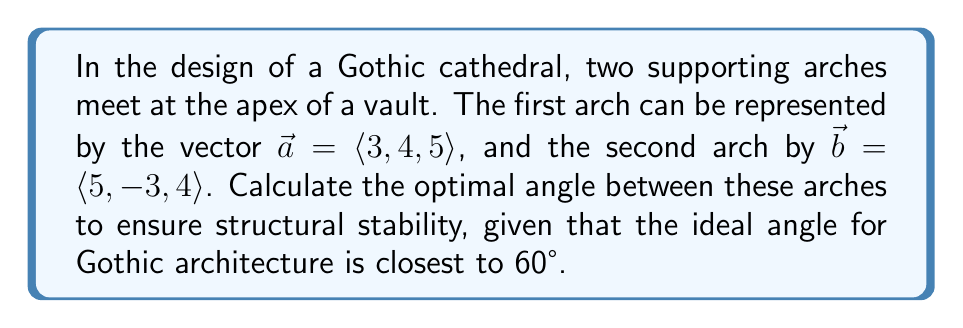Could you help me with this problem? To solve this problem, we'll follow these steps:

1) The angle between two vectors can be calculated using the dot product formula:

   $$\cos \theta = \frac{\vec{a} \cdot \vec{b}}{|\vec{a}||\vec{b}|}$$

2) First, let's calculate the dot product $\vec{a} \cdot \vec{b}$:
   
   $$\vec{a} \cdot \vec{b} = (3)(5) + (4)(-3) + (5)(4) = 15 - 12 + 20 = 23$$

3) Next, we need to calculate the magnitudes of $\vec{a}$ and $\vec{b}$:

   $$|\vec{a}| = \sqrt{3^2 + 4^2 + 5^2} = \sqrt{9 + 16 + 25} = \sqrt{50} = 5\sqrt{2}$$
   $$|\vec{b}| = \sqrt{5^2 + (-3)^2 + 4^2} = \sqrt{25 + 9 + 16} = \sqrt{50} = 5\sqrt{2}$$

4) Now we can substitute these values into our original formula:

   $$\cos \theta = \frac{23}{(5\sqrt{2})(5\sqrt{2})} = \frac{23}{50} = 0.46$$

5) To find $\theta$, we take the inverse cosine (arccos) of both sides:

   $$\theta = \arccos(0.46) \approx 62.6°$$

6) This angle is very close to the ideal 60° for Gothic architecture, differing by only about 2.6°.
Answer: 62.6° 